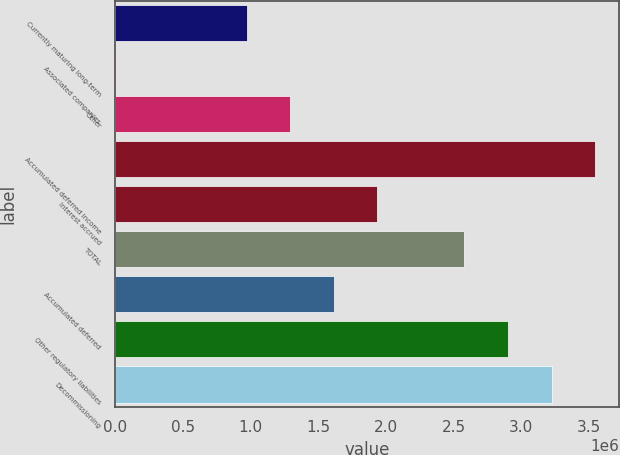Convert chart to OTSL. <chart><loc_0><loc_0><loc_500><loc_500><bar_chart><fcel>Currently maturing long-term<fcel>Associated companies<fcel>Other<fcel>Accumulated deferred income<fcel>Interest accrued<fcel>TOTAL<fcel>Accumulated deferred<fcel>Other regulatory liabilities<fcel>Decommissioning<nl><fcel>971785<fcel>6520<fcel>1.29354e+06<fcel>3.54582e+06<fcel>1.93705e+06<fcel>2.58056e+06<fcel>1.6153e+06<fcel>2.90232e+06<fcel>3.22407e+06<nl></chart> 